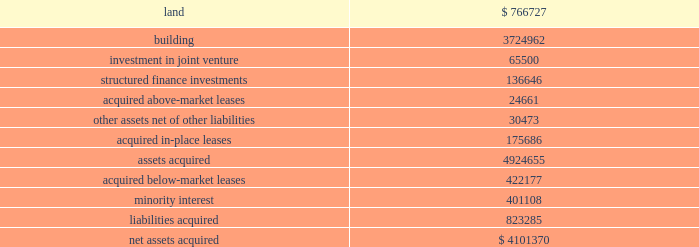Notes to consolidated financial statements in march 2008 , the fasb issued guidance which requires entities to provide greater transparency about ( a ) how and why an entity uses derivative instruments , ( b ) how derivative instruments and related hedged items are accounted , and ( c ) how derivative instruments and related hedged items affect an entity 2019s financial position , results of operations , and cash flows .
This guidance was effective on january 1 , 2009 .
The adoption of this guidance did not have a material impact on our consolidated financial statements .
In june 2009 , the fasb issued guidance on accounting for transfers of financial assets .
This guidance amends various components of the existing guidance governing sale accounting , including the recog- nition of assets obtained and liabilities assumed as a result of a transfer , and considerations of effective control by a transferor over transferred assets .
In addition , this guidance removes the exemption for qualifying special purpose entities from the consolidation guidance .
This guidance is effective january 1 , 2010 , with early adoption prohibited .
While the amended guidance governing sale accounting is applied on a prospec- tive basis , the removal of the qualifying special purpose entity exception will require us to evaluate certain entities for consolidation .
While we are evaluating the effect of adoption of this guidance , we currently believe that its adoption will not have a material impact on our consolidated financial statement .
In june 2009 , the fasb amended the guidance for determin- ing whether an entity is a variable interest entity , or vie , and requires the performance of a qualitative rather than a quantitative analysis to determine the primary beneficiary of a vie .
Under this guidance , an entity would be required to consolidate a vie if it has ( i ) the power to direct the activities that most significantly impact the entity 2019s economic performance and ( ii ) the obligation to absorb losses of the vie or the right to receive benefits from the vie that could be significant to the vie .
This guidance is effective for the first annual reporting period that begins after november 15 , 2009 , with early adoption prohibited .
While we are currently evaluating the effect of adoption of this guidance , we currently believe that its adoption will not have a material impact on our consoli- dated financial statements .
Note 3 / property acquisitions 2009 acquisitions during 2009 , we acquired the sub-leasehold positions at 420 lexington avenue for an aggregate purchase price of approximately $ 15.9 million .
2008 acquisitions in february 2008 , we , through our joint venture with jeff sutton , acquired the properties located at 182 broadway and 63 nassau street for approximately $ 30.0 million in the aggregate .
These properties are located adjacent to 180 broadway which we acquired in august 2007 .
As part of the acquisition we also closed on a $ 31.0 million loan which bears interest at 225 basis points over the 30-day libor .
The loan has a three-year term and two one-year extensions .
We drew down $ 21.1 mil- lion at the closing to pay the balance of the acquisition costs .
During the second quarter of 2008 , we , through a joint ven- ture with nysters , acquired various interests in the fee positions at 919 third avenue for approximately $ 32.8 million .
As a result , our joint venture controls the entire fee position .
2007 acquisitions in january 2007 , we acquired reckson for approximately $ 6.0 billion , inclusive of transaction costs .
Simultaneously , we sold approximately $ 2.0 billion of the reckson assets to an asset purchasing venture led by certain of reckson 2019s former executive management .
The transaction included the acquisition of 30 properties encompassing approximately 9.2 million square feet , of which five properties encompassing approxi- mately 4.2 million square feet are located in manhattan .
The following summarizes our allocation of the purchase price to the assets and liabilities acquired from reckson ( in thousands ) : .

For the reckson deal , was was the average cost per square foot for the properties acquired? 
Computations: ((9 * 1000) / 9.2)
Answer: 978.26087. 